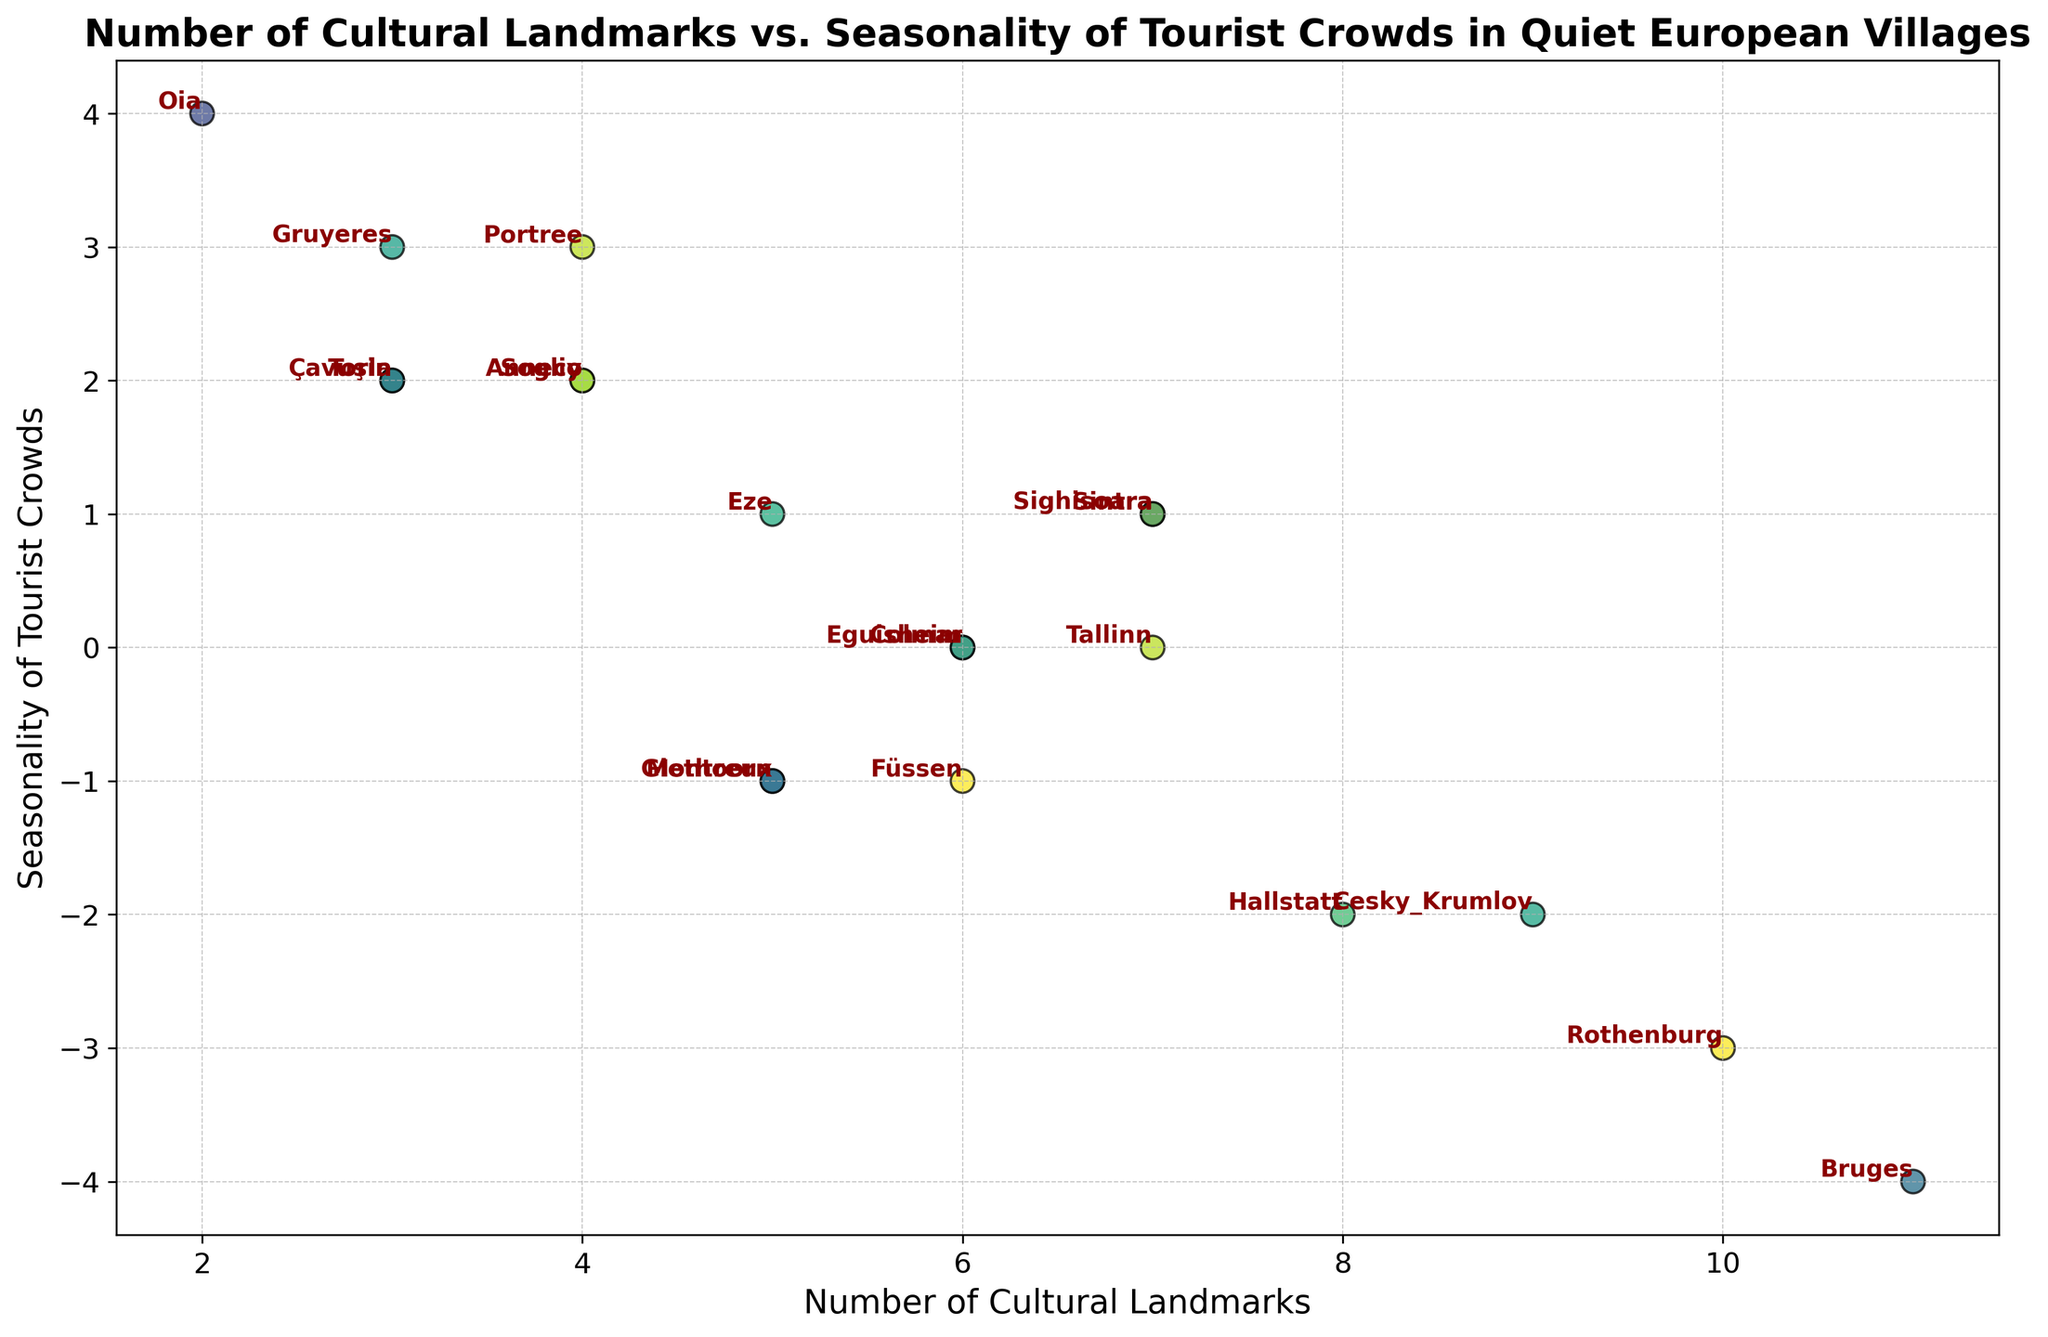Which village has the highest number of cultural landmarks? The village with the highest number of cultural landmarks is the one with the maximum value on the x-axis. From the scatter plot, the village with 11 cultural landmarks is Bruges.
Answer: Bruges Which village experiences the highest seasonality of tourist crowds? The village with the highest seasonality of tourist crowds is the one with the highest value on the y-axis. Visually, it can be seen that the village with a value of 4 on the y-axis is Oia.
Answer: Oia Which village has the least variability in tourist crowds but has more than 5 cultural landmarks? To find this, we look for villages with a Seasonality of Tourist Crowds value of 0 and Number of Cultural Landmarks greater than 5. These criteria match Tallinn and Eguisheim based on their positions in the plot.
Answer: Tallinn, Eguisheim How many villages have a negative seasonality of tourist crowds and more than 7 cultural landmarks? To determine this, count the number of points with x-values greater than 7 and y-values below 0. These points are Hallstatt, Rothenburg, Bruges, and Cesky Krumlov.
Answer: 4 Which village has the maximum positive seasonality of tourist crowds but fewer than 5 cultural landmarks? This is identified by finding the highest y-value on the plot with x-values less than 5. Portree stands out with a seasonality value of 3.
Answer: Portree What is the average number of cultural landmarks for villages with a seasonality value of 2? Villages with a seasonality value of 2 include Annecy, Soglio, Torla, and Çavuşin. Their cultural landmarks are 4, 4, 3, and 3, respectively. Sum = 4+4+3+3 = 14. Average = 14 / 4.
Answer: 3.5 Which two villages have the same number of cultural landmarks but different seasonality of tourist crowds? Point pairs with the same x-values but different y-values include Giethoorn and Eze (both with 5 cultural landmarks).
Answer: Giethoorn, Eze What is the difference in the number of cultural landmarks between the village with the highest and lowest seasonality of tourist crowds? The village with the highest seasonality of tourist crowds is Oia (y=4, x=2), and the lowest is Bruges (y=-4, x=11). Difference = 11 - 2.
Answer: 9 Which village has 7 cultural landmarks and experiences the least seasonality? Look for the point where the Number of Cultural Landmarks is 7 and Seasonality of Tourist Crowds is 0. From the plot, this village is Tallinn.
Answer: Tallinn Among villages with negative seasonality of tourist crowds, which has the fewest cultural landmarks? Within villages that have negative y-values, identify the point with the lowest x-value. The village is Füssen with 6 cultural landmarks and a seasonality of -1.
Answer: Füssen 